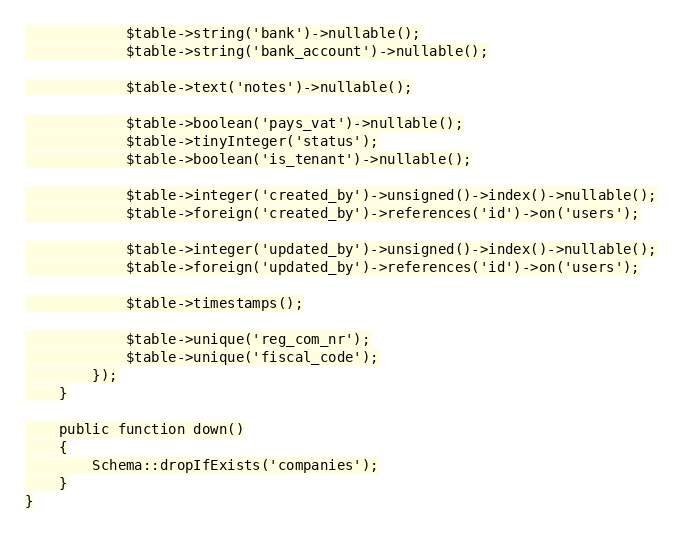<code> <loc_0><loc_0><loc_500><loc_500><_PHP_>
            $table->string('bank')->nullable();
            $table->string('bank_account')->nullable();

            $table->text('notes')->nullable();

            $table->boolean('pays_vat')->nullable();
            $table->tinyInteger('status');
            $table->boolean('is_tenant')->nullable();

            $table->integer('created_by')->unsigned()->index()->nullable();
            $table->foreign('created_by')->references('id')->on('users');

            $table->integer('updated_by')->unsigned()->index()->nullable();
            $table->foreign('updated_by')->references('id')->on('users');

            $table->timestamps();

            $table->unique('reg_com_nr');
            $table->unique('fiscal_code');
        });
    }

    public function down()
    {
        Schema::dropIfExists('companies');
    }
}
</code> 